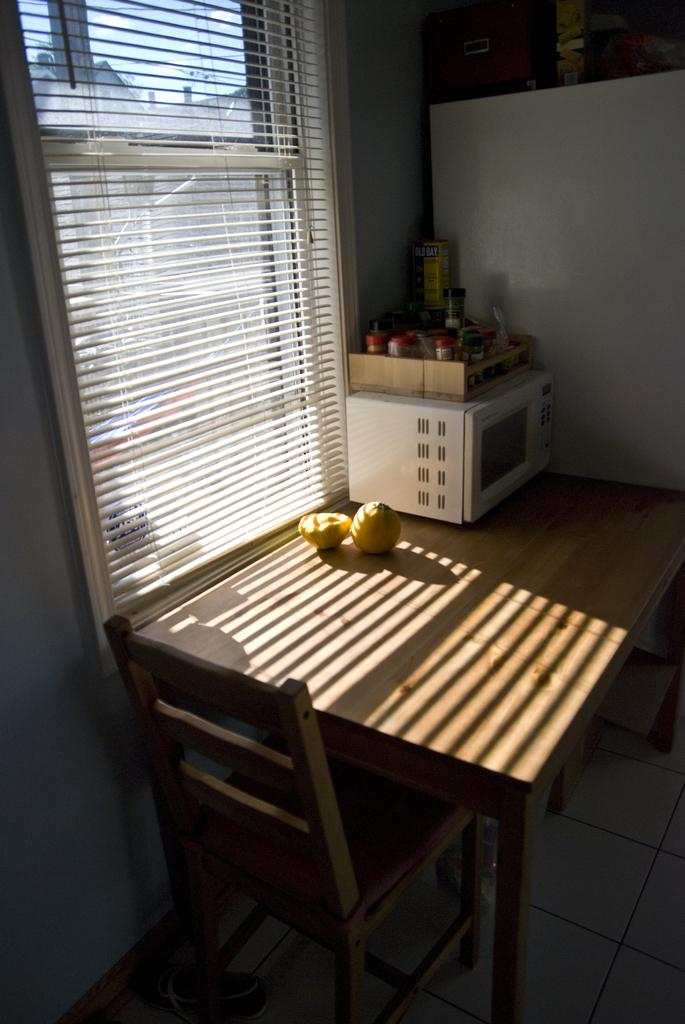What type of food items can be seen in the image? There are fruits in the image. What appliance is present on the table in the image? There is an oven on a table in the image. What type of furniture is in the image? There is a chair in the image. What can be seen in the background of the image? There is a window blind and the sky visible in the background of the image. What is the color of the sky in the image? The color of the sky in the image is described as white. What type of vest is being worn by the fruit in the image? There are no vests present in the image, and the fruits are not wearing any clothing. What observation can be made about the relation between the oven and the chair in the image? There is no specific relation between the oven and the chair mentioned in the facts, so we cannot make any observations about their connection. 